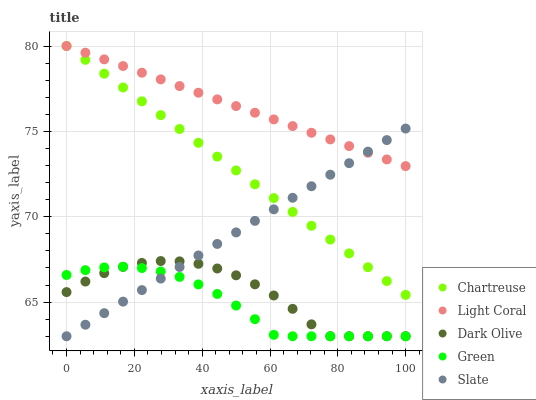Does Green have the minimum area under the curve?
Answer yes or no. Yes. Does Light Coral have the maximum area under the curve?
Answer yes or no. Yes. Does Chartreuse have the minimum area under the curve?
Answer yes or no. No. Does Chartreuse have the maximum area under the curve?
Answer yes or no. No. Is Chartreuse the smoothest?
Answer yes or no. Yes. Is Dark Olive the roughest?
Answer yes or no. Yes. Is Dark Olive the smoothest?
Answer yes or no. No. Is Chartreuse the roughest?
Answer yes or no. No. Does Dark Olive have the lowest value?
Answer yes or no. Yes. Does Chartreuse have the lowest value?
Answer yes or no. No. Does Chartreuse have the highest value?
Answer yes or no. Yes. Does Dark Olive have the highest value?
Answer yes or no. No. Is Green less than Light Coral?
Answer yes or no. Yes. Is Chartreuse greater than Green?
Answer yes or no. Yes. Does Light Coral intersect Slate?
Answer yes or no. Yes. Is Light Coral less than Slate?
Answer yes or no. No. Is Light Coral greater than Slate?
Answer yes or no. No. Does Green intersect Light Coral?
Answer yes or no. No. 